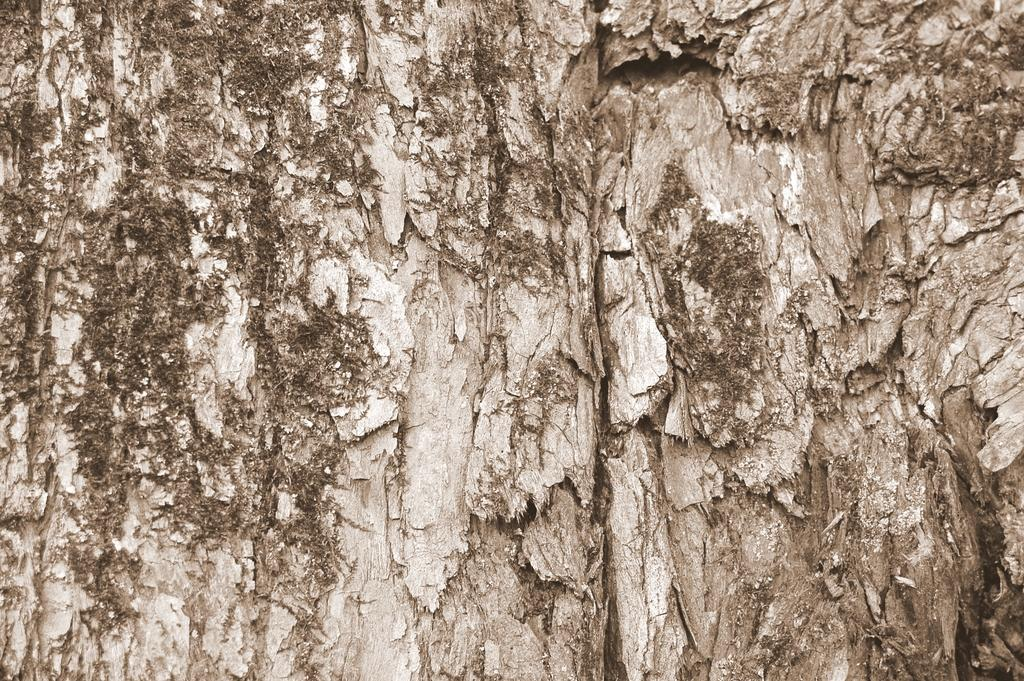What is the main subject of the image? The main subject of the image is the bark of a tree. What color scheme is used in the image? The image is in black and white. How many friends are visible in the image? There are no friends present in the image, as it depicts the bark of a tree. What type of cloth is draped over the tree in the image? There is no cloth draped over the tree in the image; it only shows the bark. 